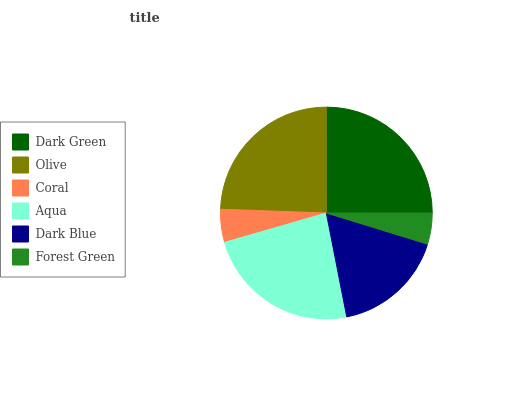Is Forest Green the minimum?
Answer yes or no. Yes. Is Dark Green the maximum?
Answer yes or no. Yes. Is Olive the minimum?
Answer yes or no. No. Is Olive the maximum?
Answer yes or no. No. Is Dark Green greater than Olive?
Answer yes or no. Yes. Is Olive less than Dark Green?
Answer yes or no. Yes. Is Olive greater than Dark Green?
Answer yes or no. No. Is Dark Green less than Olive?
Answer yes or no. No. Is Aqua the high median?
Answer yes or no. Yes. Is Dark Blue the low median?
Answer yes or no. Yes. Is Coral the high median?
Answer yes or no. No. Is Aqua the low median?
Answer yes or no. No. 